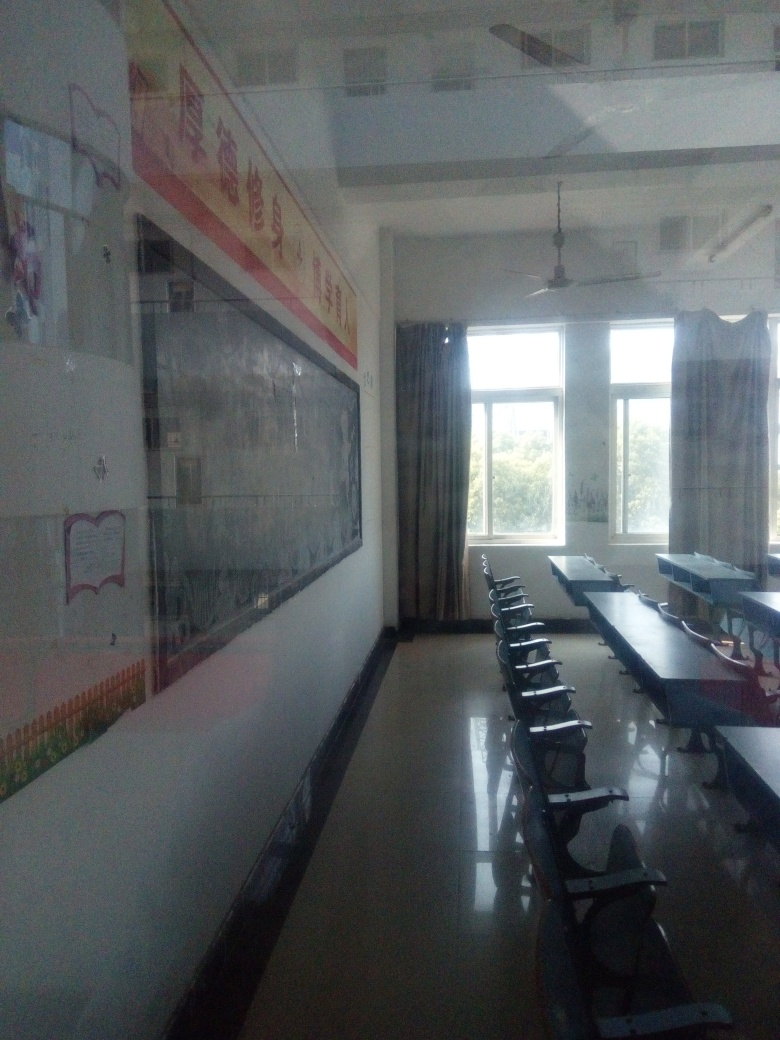How would you describe the composition of the image? A. Unique B. Exceptional C. Imbalanced D. Ordinary Answer with the option's letter from the given choices directly. The composition of the image can be described as D. Ordinary, because it presents a standard classroom setting without any unusual or distinctive elements that stand out as particularly unique or exceptional. The regular arrangement of desks and chairs, along with the educational posters on the walls, are typical features found in many educational environments. 